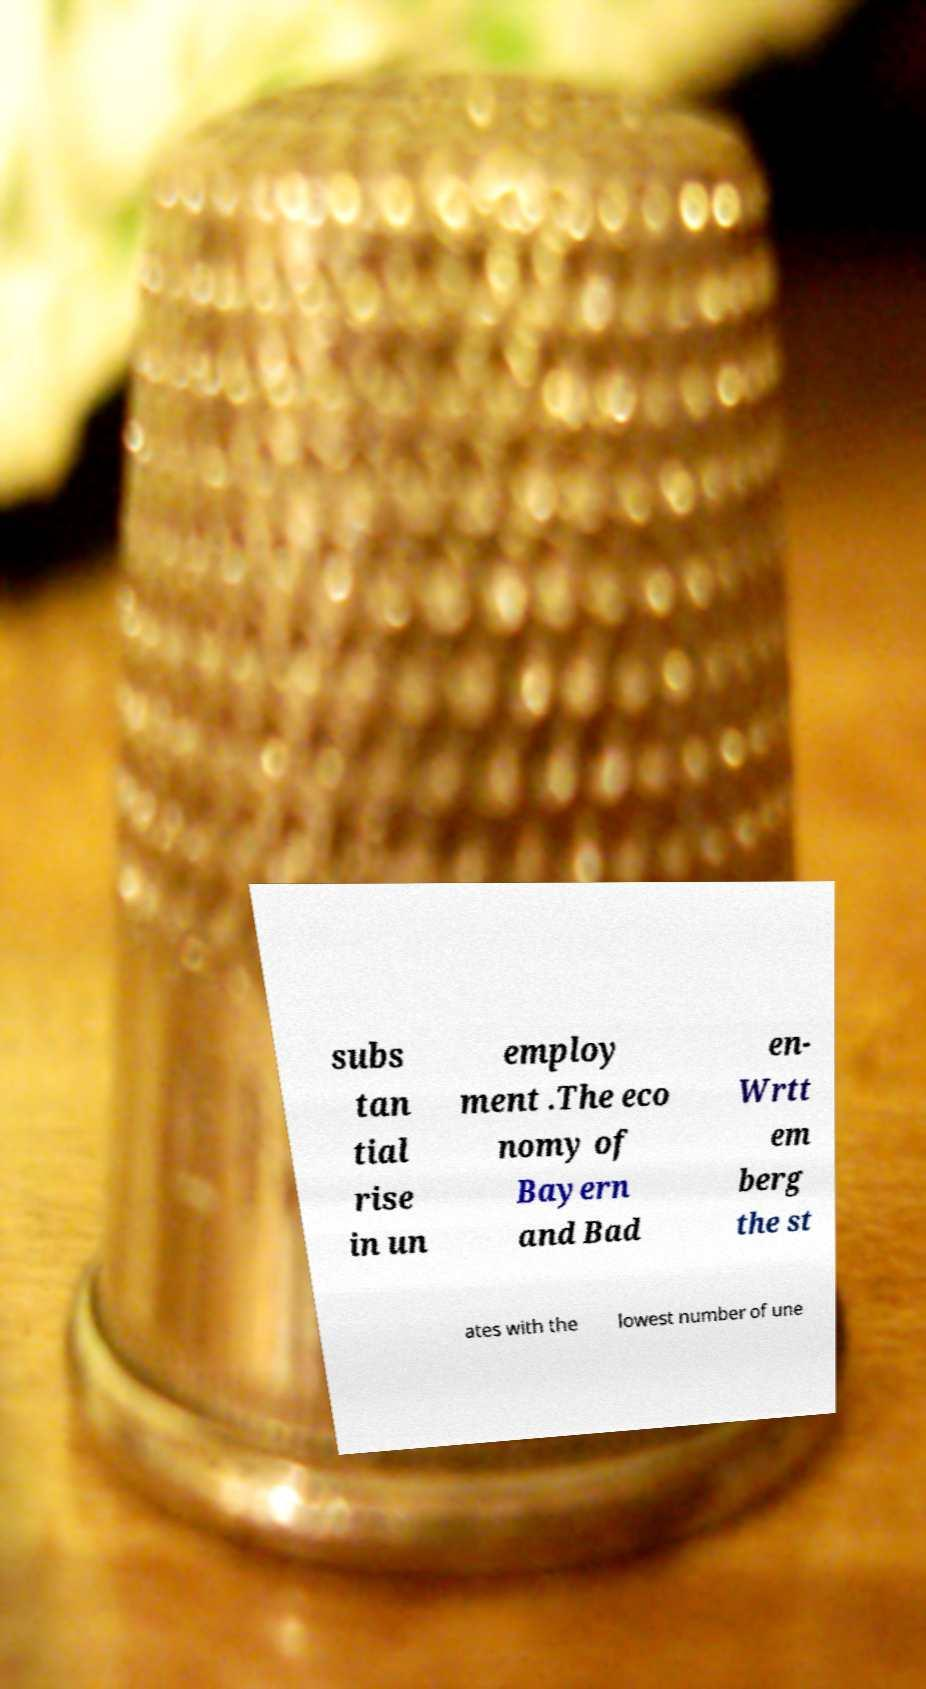I need the written content from this picture converted into text. Can you do that? subs tan tial rise in un employ ment .The eco nomy of Bayern and Bad en- Wrtt em berg the st ates with the lowest number of une 